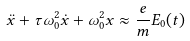Convert formula to latex. <formula><loc_0><loc_0><loc_500><loc_500>\ddot { x } + \tau \omega _ { 0 } ^ { 2 } \dot { x } + \omega _ { 0 } ^ { 2 } x \approx { \frac { e } { m } } E _ { 0 } ( t )</formula> 